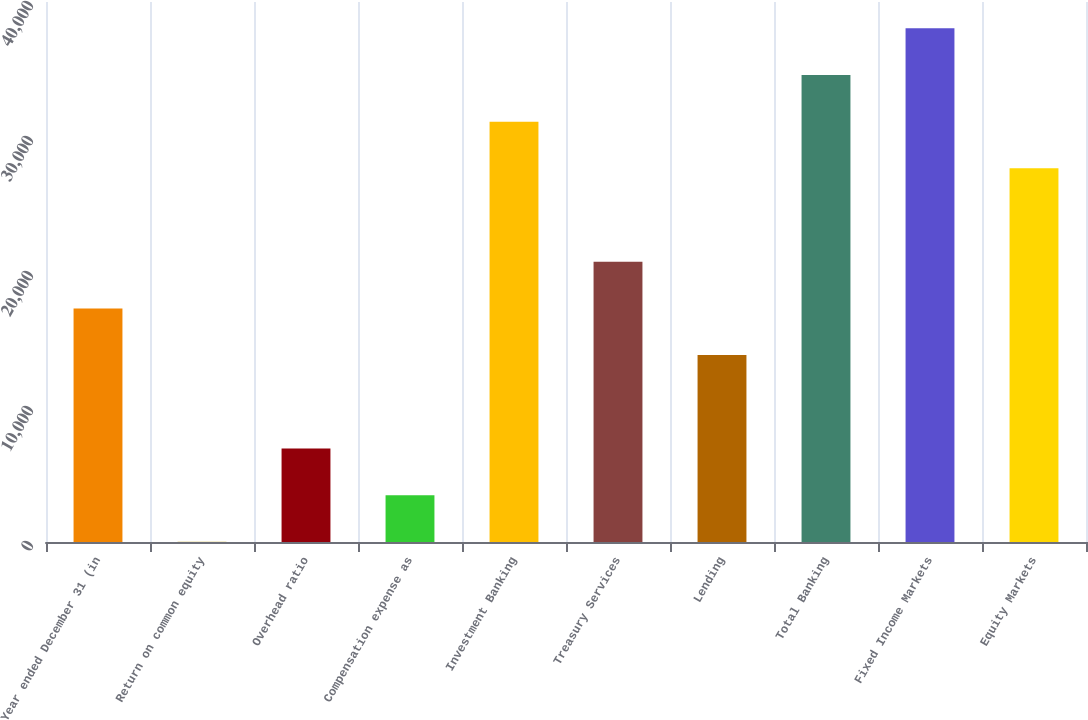Convert chart to OTSL. <chart><loc_0><loc_0><loc_500><loc_500><bar_chart><fcel>Year ended December 31 (in<fcel>Return on common equity<fcel>Overhead ratio<fcel>Compensation expense as<fcel>Investment Banking<fcel>Treasury Services<fcel>Lending<fcel>Total Banking<fcel>Fixed Income Markets<fcel>Equity Markets<nl><fcel>17302.5<fcel>10<fcel>6927<fcel>3468.5<fcel>31136.5<fcel>20761<fcel>13844<fcel>34595<fcel>38053.5<fcel>27678<nl></chart> 